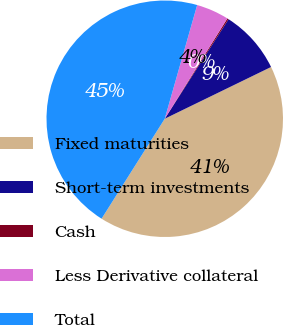<chart> <loc_0><loc_0><loc_500><loc_500><pie_chart><fcel>Fixed maturities<fcel>Short-term investments<fcel>Cash<fcel>Less Derivative collateral<fcel>Total<nl><fcel>41.18%<fcel>8.72%<fcel>0.19%<fcel>4.46%<fcel>45.45%<nl></chart> 